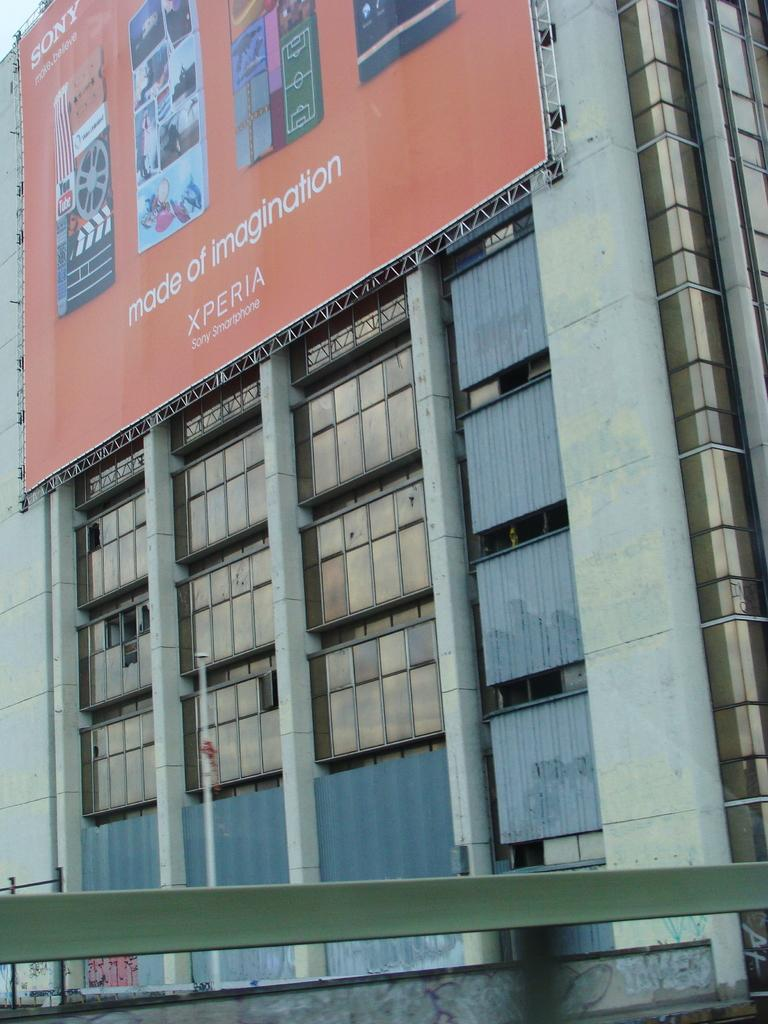What is the main subject of the big poster in the image? The main subject of the big poster in the image is Xperia Sony smartphones. What thrilling activity is the grandfather participating in with his partner in the image? There is no grandfather or partner present in the image, and no thrilling activity is depicted. 